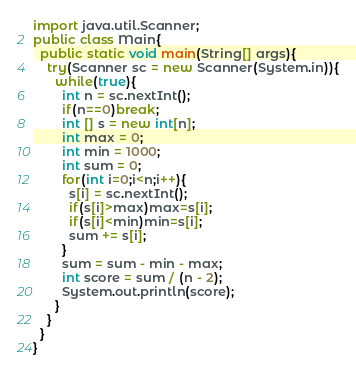Convert code to text. <code><loc_0><loc_0><loc_500><loc_500><_Java_>import java.util.Scanner;
public class Main{
  public static void main(String[] args){
    try(Scanner sc = new Scanner(System.in)){
      while(true){
        int n = sc.nextInt();
        if(n==0)break;
        int [] s = new int[n];
        int max = 0;
        int min = 1000;
        int sum = 0;
        for(int i=0;i<n;i++){
          s[i] = sc.nextInt();
          if(s[i]>max)max=s[i];
          if(s[i]<min)min=s[i];
          sum += s[i];
        }
        sum = sum - min - max;
        int score = sum / (n - 2);
        System.out.println(score);
      }
    }
  }
}

</code> 